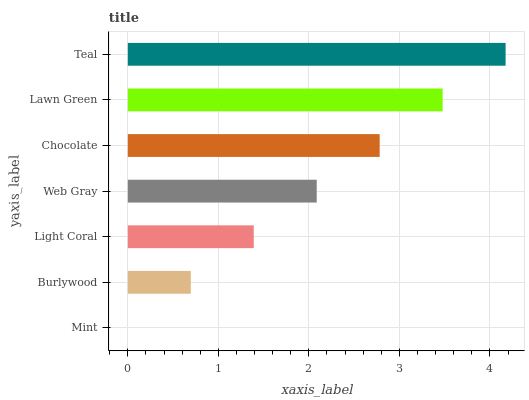Is Mint the minimum?
Answer yes or no. Yes. Is Teal the maximum?
Answer yes or no. Yes. Is Burlywood the minimum?
Answer yes or no. No. Is Burlywood the maximum?
Answer yes or no. No. Is Burlywood greater than Mint?
Answer yes or no. Yes. Is Mint less than Burlywood?
Answer yes or no. Yes. Is Mint greater than Burlywood?
Answer yes or no. No. Is Burlywood less than Mint?
Answer yes or no. No. Is Web Gray the high median?
Answer yes or no. Yes. Is Web Gray the low median?
Answer yes or no. Yes. Is Teal the high median?
Answer yes or no. No. Is Chocolate the low median?
Answer yes or no. No. 